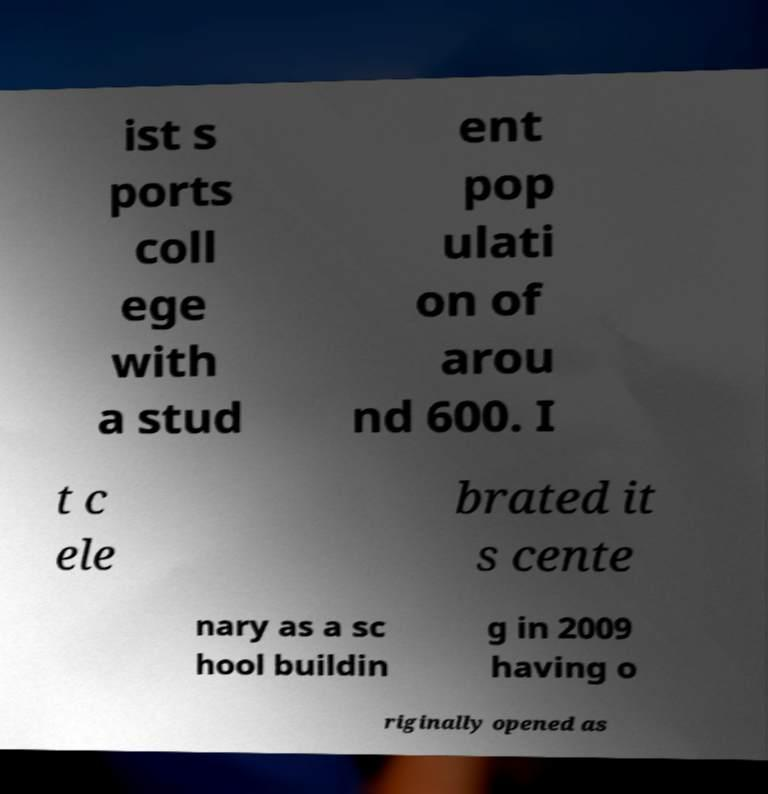Please read and relay the text visible in this image. What does it say? ist s ports coll ege with a stud ent pop ulati on of arou nd 600. I t c ele brated it s cente nary as a sc hool buildin g in 2009 having o riginally opened as 